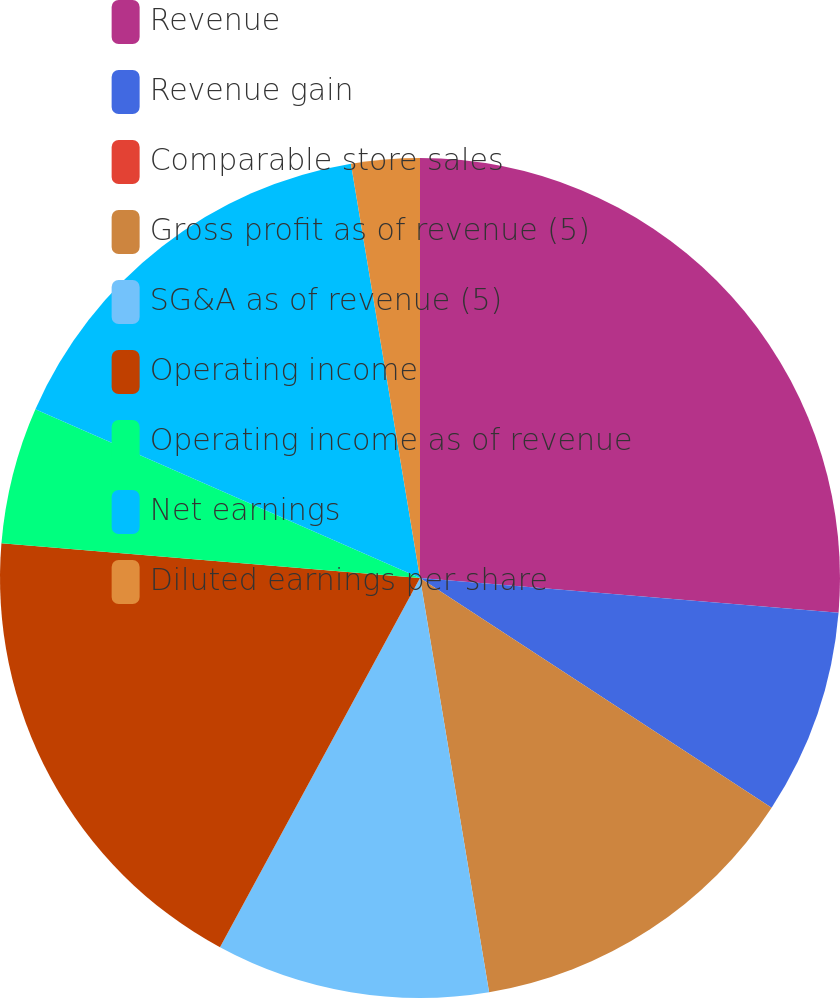Convert chart to OTSL. <chart><loc_0><loc_0><loc_500><loc_500><pie_chart><fcel>Revenue<fcel>Revenue gain<fcel>Comparable store sales<fcel>Gross profit as of revenue (5)<fcel>SG&A as of revenue (5)<fcel>Operating income<fcel>Operating income as of revenue<fcel>Net earnings<fcel>Diluted earnings per share<nl><fcel>26.32%<fcel>7.89%<fcel>0.0%<fcel>13.16%<fcel>10.53%<fcel>18.42%<fcel>5.26%<fcel>15.79%<fcel>2.63%<nl></chart> 